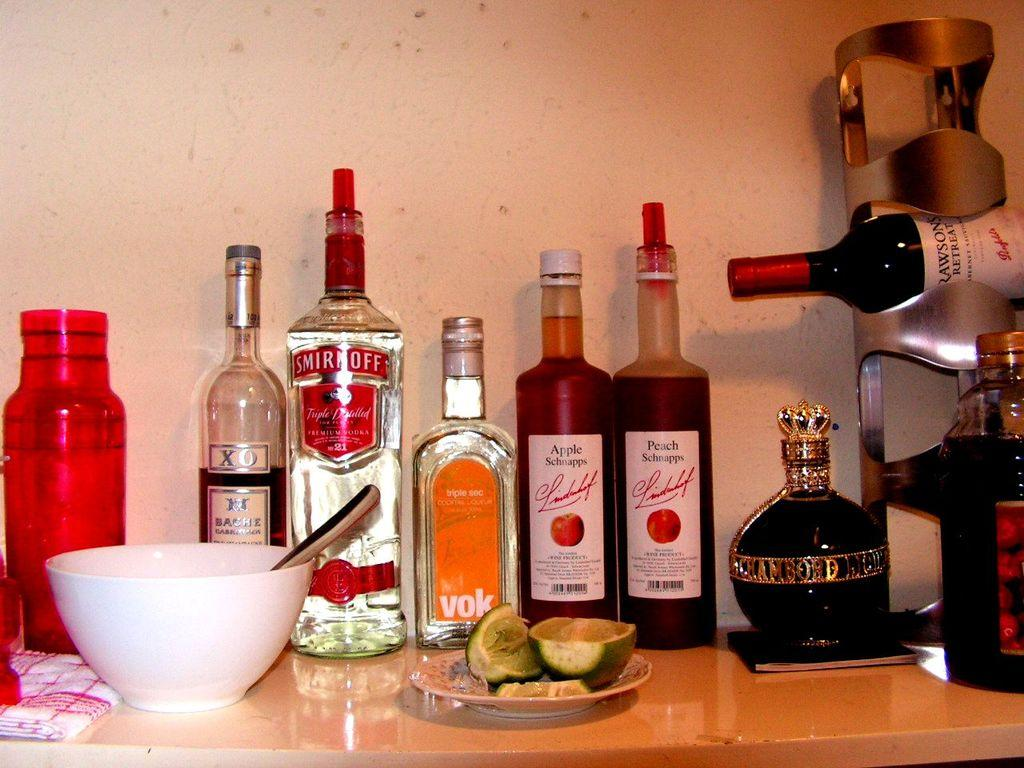Provide a one-sentence caption for the provided image. Several bottles of alchohol including Smirnoff, Apple Schnapps, and Peach Schnapps are lined up against a wall. 